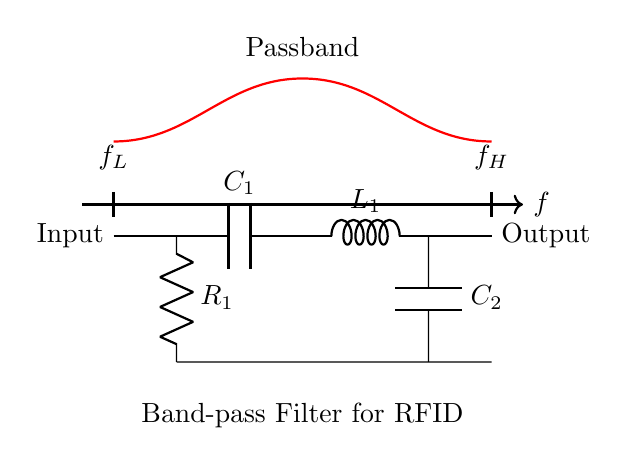What components are present in the circuit? The diagram shows three main components: a capacitor, an inductor, and a resistor, labeled as C1, L1, and R1.
Answer: Capacitor, Inductor, Resistor What is the output of the circuit? The output is indicated at the right side of the diagram, connected to point labeled "Output". This implies that the signal processed by the filter is available at this point.
Answer: Output What type of filter is represented in the circuit? The circuit is specifically labeled as a "Band-pass Filter," which indicates its purpose to allow a range of frequencies to pass through while attenuating frequencies outside this range.
Answer: Band-pass Filter What are the labeled frequency limits for the passband? The circuit labels two specific frequencies, one at the left side "f_L" representing the lower frequency limit and another at the right "f_H" representing the upper frequency limit, which define the band of interest for the filter.
Answer: f_L and f_H How does the band-pass filter affect signal frequencies? The band-pass filter allows signal frequencies between the lower and upper frequency limits (f_L and f_H) to pass while attenuating frequencies outside this range. Therefore, frequencies below f_L and above f_H will be blocked.
Answer: Attenuates outside frequencies What role does the inductor play in the circuit? The inductor in this circuit, labeled as L1, contributes to the frequency-selective characteristics of the band-pass filter, allowing certain frequencies to pass while blocking others. Inductors generally react to changes in current, impacting the impedance at different frequencies.
Answer: Frequency selectivity Which component primarily determines the lower frequency limit of the filter? The lower frequency limit (f_L) is primarily determined by the capacitor C1 and its interaction with the inductor L1, as the capacitive reactance decreases with increasing frequency, allowing lower frequencies to pass through.
Answer: Capacitor C1 